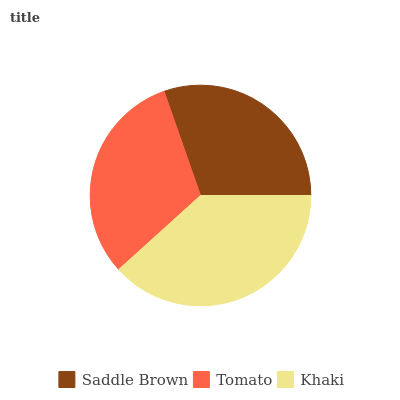Is Saddle Brown the minimum?
Answer yes or no. Yes. Is Khaki the maximum?
Answer yes or no. Yes. Is Tomato the minimum?
Answer yes or no. No. Is Tomato the maximum?
Answer yes or no. No. Is Tomato greater than Saddle Brown?
Answer yes or no. Yes. Is Saddle Brown less than Tomato?
Answer yes or no. Yes. Is Saddle Brown greater than Tomato?
Answer yes or no. No. Is Tomato less than Saddle Brown?
Answer yes or no. No. Is Tomato the high median?
Answer yes or no. Yes. Is Tomato the low median?
Answer yes or no. Yes. Is Khaki the high median?
Answer yes or no. No. Is Saddle Brown the low median?
Answer yes or no. No. 